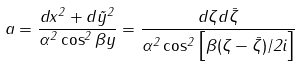<formula> <loc_0><loc_0><loc_500><loc_500>a = \frac { d x ^ { 2 } + d \tilde { y } ^ { 2 } } { \alpha ^ { 2 } \cos ^ { 2 } \beta y } = \frac { d \zeta d \bar { \zeta } } { \alpha ^ { 2 } \cos ^ { 2 } \left [ \beta ( \zeta - \bar { \zeta } ) / 2 i \right ] }</formula> 